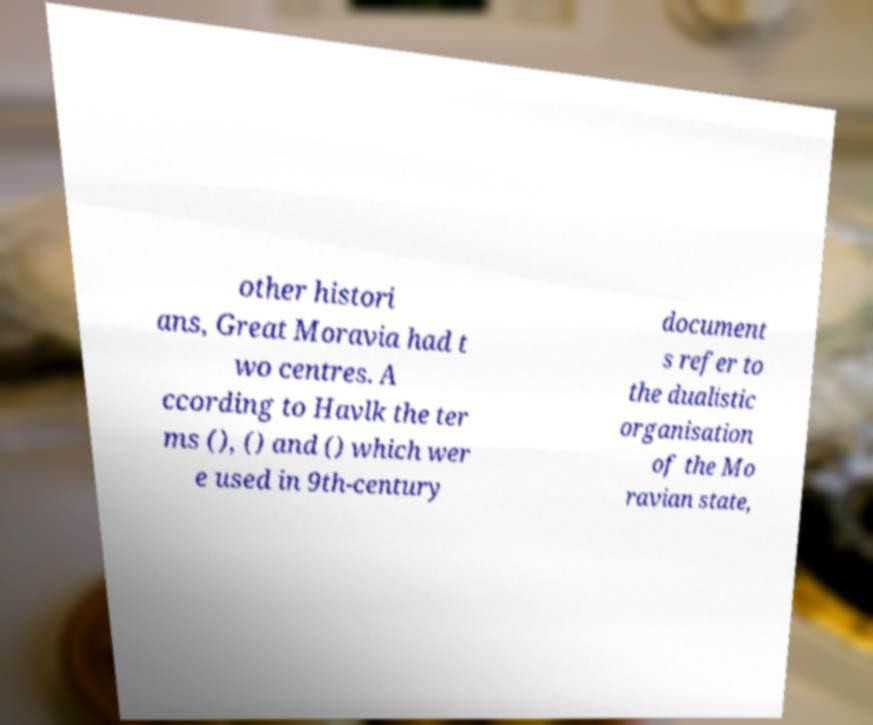For documentation purposes, I need the text within this image transcribed. Could you provide that? other histori ans, Great Moravia had t wo centres. A ccording to Havlk the ter ms (), () and () which wer e used in 9th-century document s refer to the dualistic organisation of the Mo ravian state, 